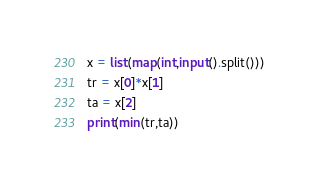Convert code to text. <code><loc_0><loc_0><loc_500><loc_500><_Python_>x = list(map(int,input().split()))
tr = x[0]*x[1]
ta = x[2]
print(min(tr,ta))</code> 